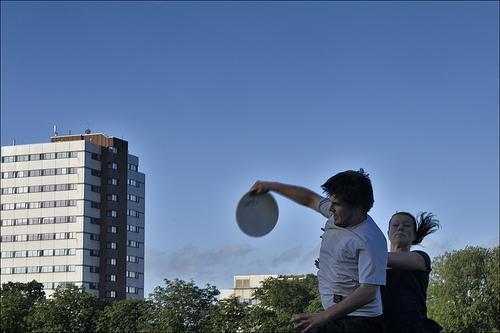How many players?
Give a very brief answer. 2. 